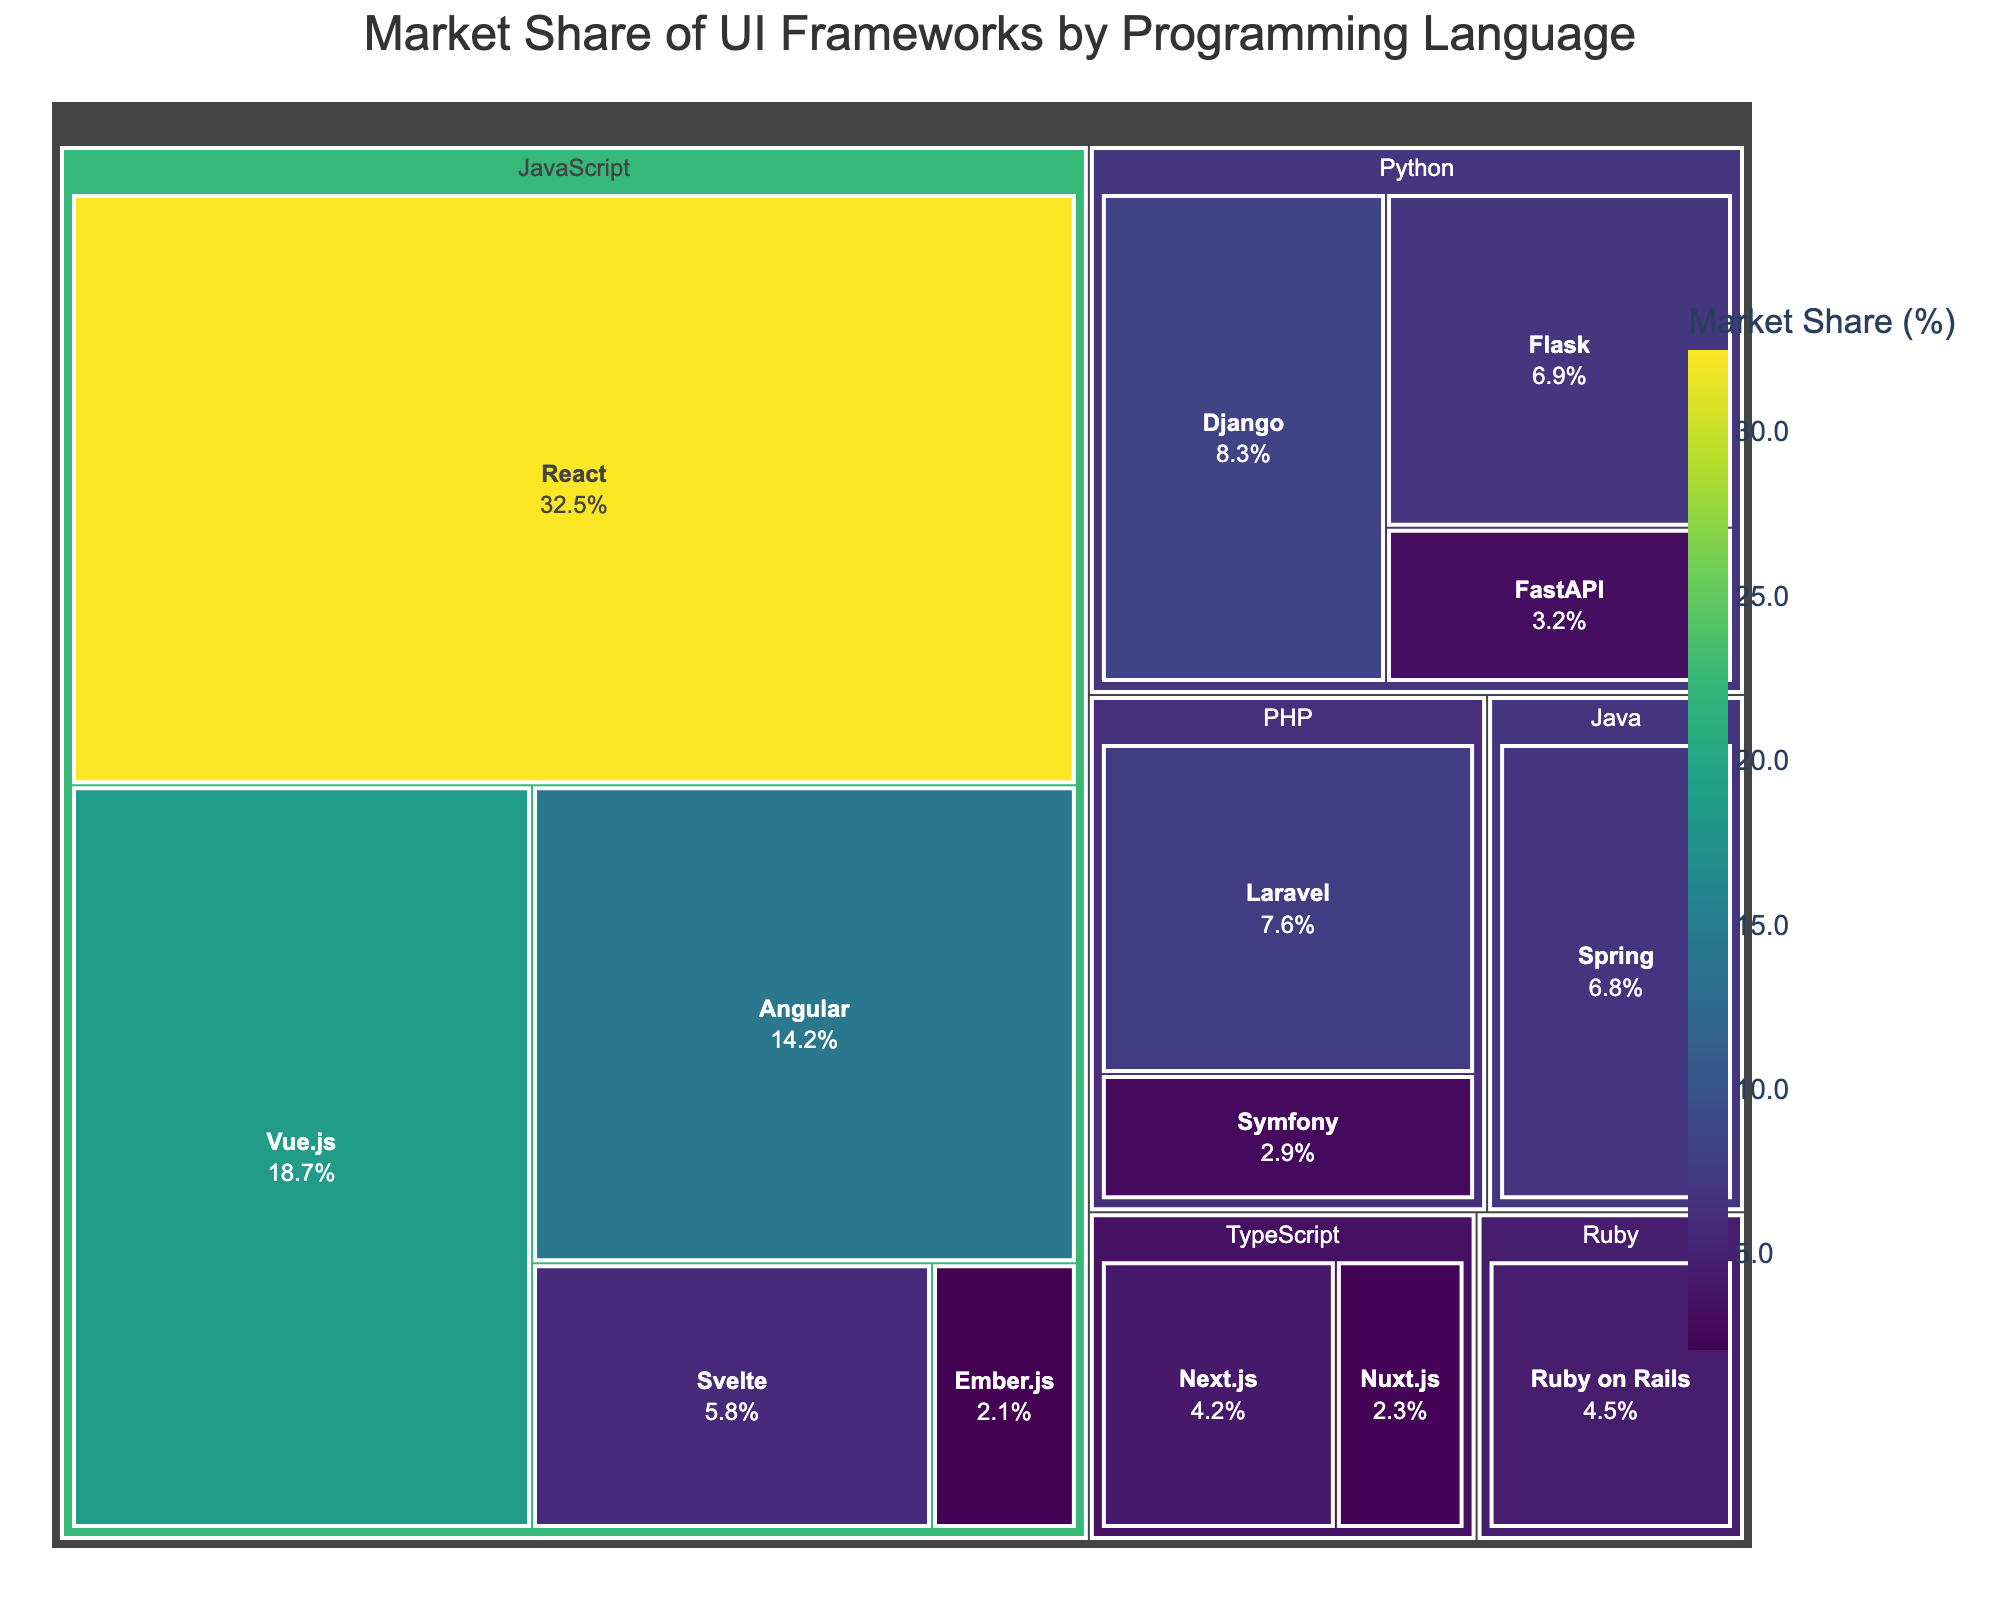What's the title of the treemap? Look at the top of the figure where the title is prominently displayed.
Answer: Market Share of UI Frameworks by Programming Language Which framework has the largest market share among JavaScript frameworks? Find the section of the treemap labeled with JavaScript and identify the framework with the largest area and the highest market share percentage within that group.
Answer: React What is the total market share of Python frameworks combined? Sum the market share percentages of all Python frameworks (Django, Flask, FastAPI). Django: 8.3%, Flask: 6.9%, FastAPI: 3.2%. Total = 8.3 + 6.9 + 3.2
Answer: 18.4% Which PHP framework has a larger market share? Observe the sizes of the areas labeled within the PHP section and compare the market share percentages to determine which is larger.
Answer: Laravel How does the market share of Angular compare to that of Flask? Refer to the sections corresponding to Angular and Flask. Angular's market share is 14.2% and Flask's is 6.9%. Compare these two numbers.
Answer: Angular has a greater market share What is the difference in market share between Next.js and Nuxt.js? Locate the sections for Next.js and Nuxt.js within the TypeScript group and subtract Nuxt.js's market share from Next.js's. Next.js: 4.2%, Nuxt.js: 2.3%. Difference = 4.2 - 2.3
Answer: 1.9% Among Ruby, which framework is represented and what is its market share? Find the section labeled Ruby and identify the framework and its percentage.
Answer: Ruby on Rails, 4.5% In terms of market share, how does Svelte compare to Symfony? Locate the sections for Svelte and Symfony. Compare their market shares: Svelte has 5.8%, Symphony has 2.9%.
Answer: Svelte has a greater market share Which language has the highest number of frameworks represented, and how many are there? Count the number of frameworks listed under each programming language, and identify the language with the highest count. JavaScript has React, Vue.js, Angular, Svelte, Ember.js, totaling 5.
Answer: JavaScript, 5 What is the overall market share for frameworks associated with Java? Find the section labeled Java and observe the market share for Spring, as it is the only framework listed.
Answer: 6.8% 